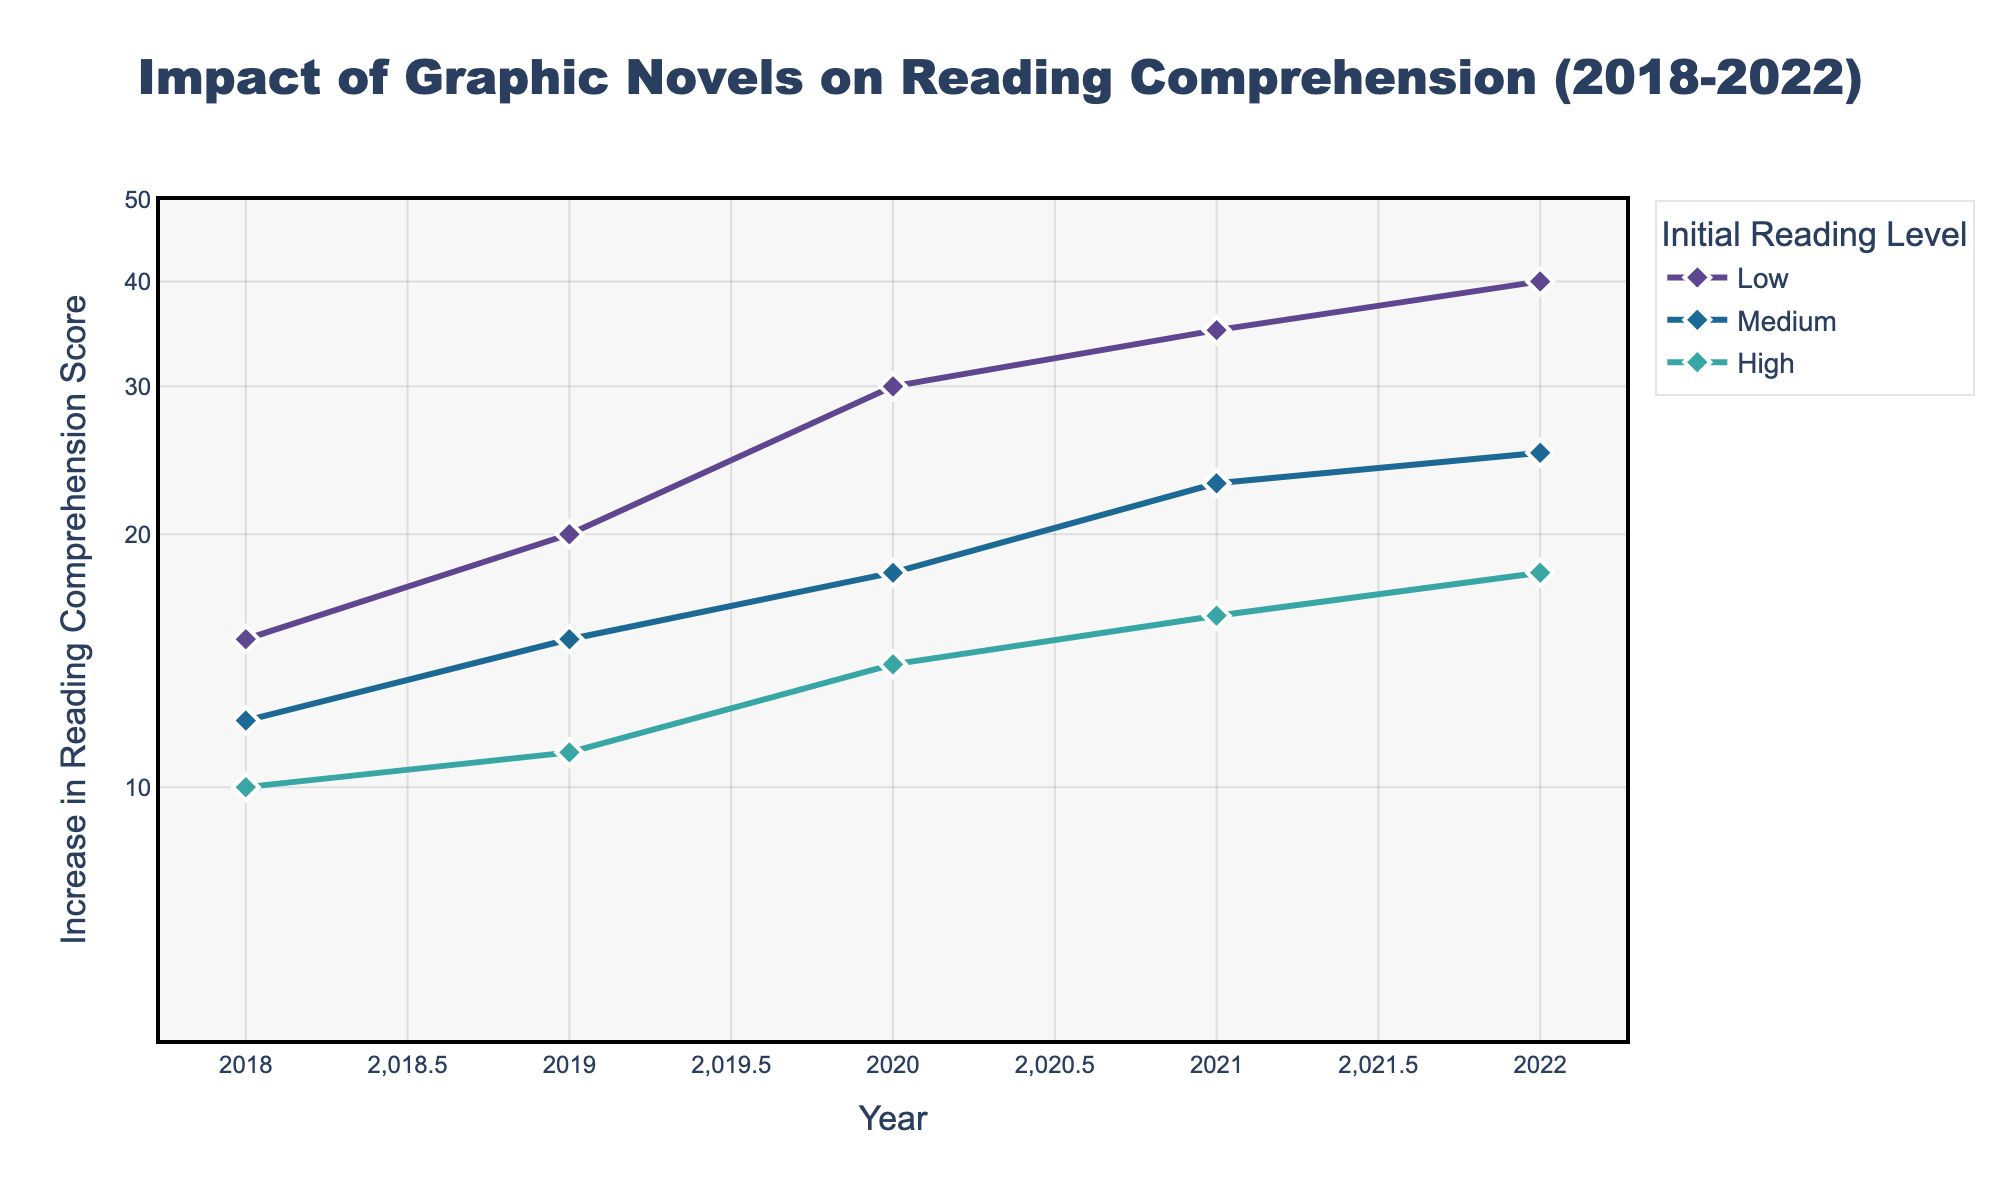What is the title of the figure? The title can be found at the top of the figure, generally in larger and bold font. In this case, it is stated as "Impact of Graphic Novels on Reading Comprehension (2018-2022)".
Answer: Impact of Graphic Novels on Reading Comprehension (2018-2022) What are the axes labels in the figure? The labels are present on the horizontal and vertical axes. The x-axis is labeled "Year" and the y-axis is labeled "Increase in Reading Comprehension Score".
Answer: Year and Increase in Reading Comprehension Score Which initial reading level showed the highest increase in reading comprehension score in 2022? By observing the data points for 2022, the initial reading level "Low" showed the highest increase in score, rising to 40.
Answer: Low What are the initial reading levels represented in the figure? Different lines and markers represent various initial reading levels. These levels are specified in the legend. In the figure, the initial reading levels are "Low," "Medium," and "High."
Answer: Low, Medium, and High How did the reading comprehension scores for the "Medium" initial reading level change from 2018 to 2022? To find this, observe the trend line for "Medium" from 2018 to 2022. The reading comprehension scores increased from 12 in 2018 to 25 in 2022.
Answer: Increased from 12 to 25 Which year observed the largest increase in reading comprehension scores for the "High" initial reading level? By analyzing the trend lines, you can see that the largest increase for the "High" initial reading level occurred between 2020 (score of 14) and 2021 (score of 16). This is an increase of 2, which is the largest compared to other years.
Answer: 2021 What is the range of y-values depicted in the figure? The y-axis uses a logarithmic scale, displaying values from 10 to 50. These values are specific tick marks on the y-axis.
Answer: 10 to 50 Compare the increase in reading comprehension scores between "Low" and "High" initial reading levels in 2022. The score for "Low" in 2022 is 40, and for "High," it is 18. Subtracting 18 from 40 gives a difference of 22.
Answer: The difference is 22 What trend do you observe for the "Low" initial reading level across the years? Look at the trend line for "Low" initial reading level from 2018 to 2022. The line generally shows an upward trend, indicating a continuous increase in reading comprehension scores over the years.
Answer: Continuous increase By what factor did the "Low" initial reading level's reading comprehension score increase from 2018 to 2022? The score increased from 15 in 2018 to 40 in 2022. The factor of increase is 40 divided by 15, which is approximately 2.67.
Answer: Approximately 2.67 